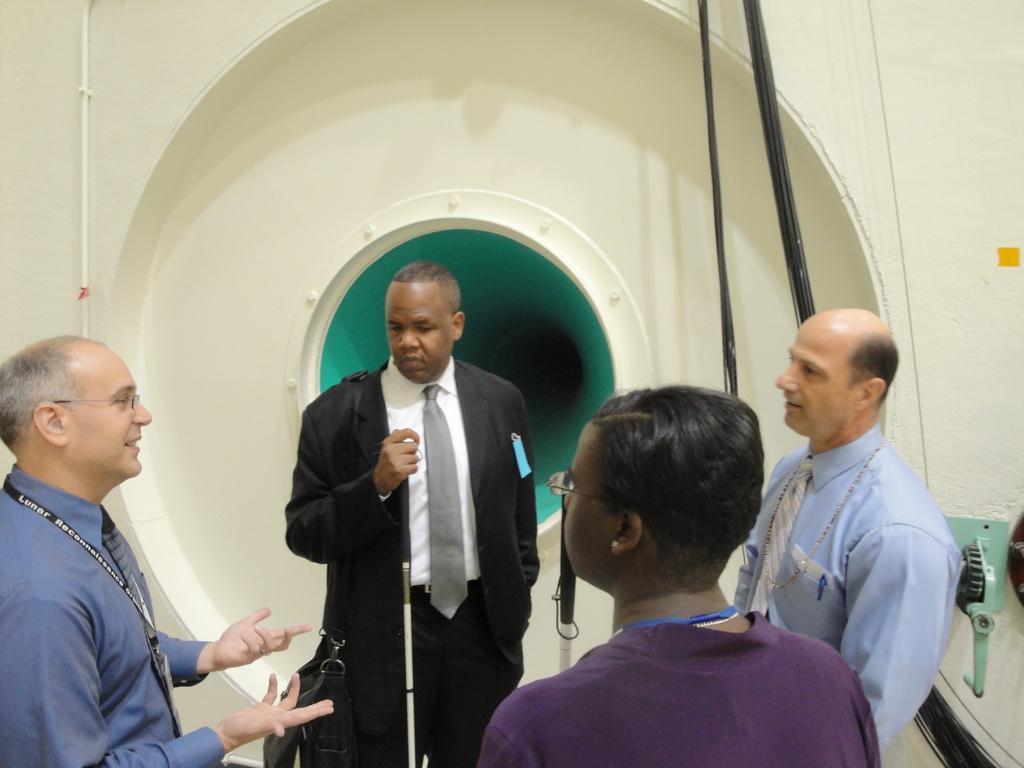Could you give a brief overview of what you see in this image? In this image we can see some people standing. In that a person is holding a stick. On the backside we can see a window, wires and a wall. 